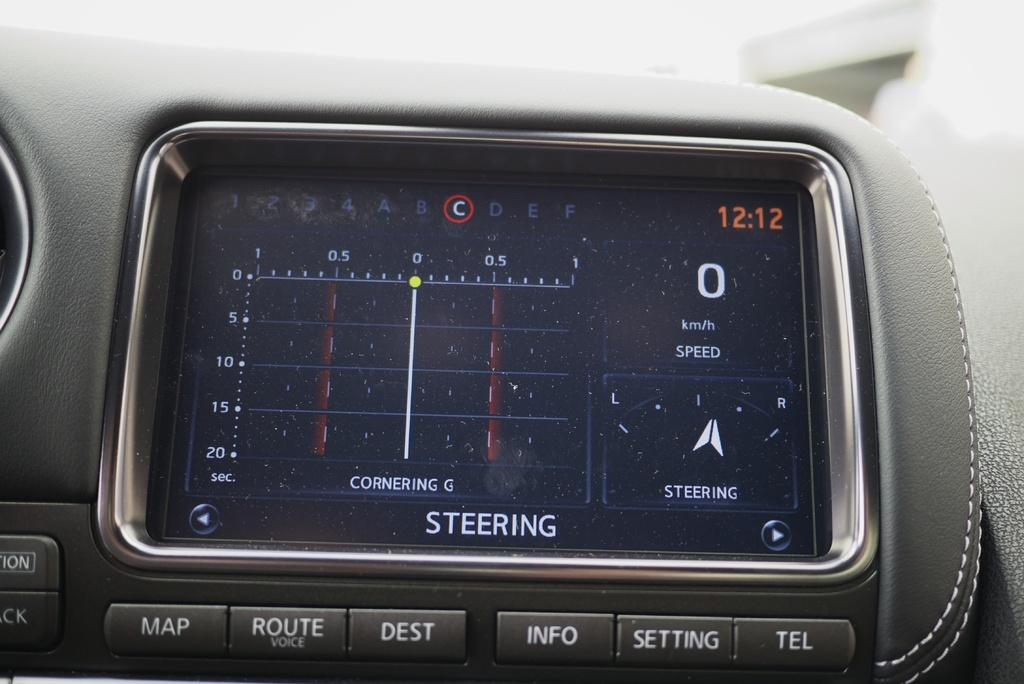<image>
Share a concise interpretation of the image provided. A steering device is built into a car dashboard showing the time and attributes related to current steering of the vehicle. 